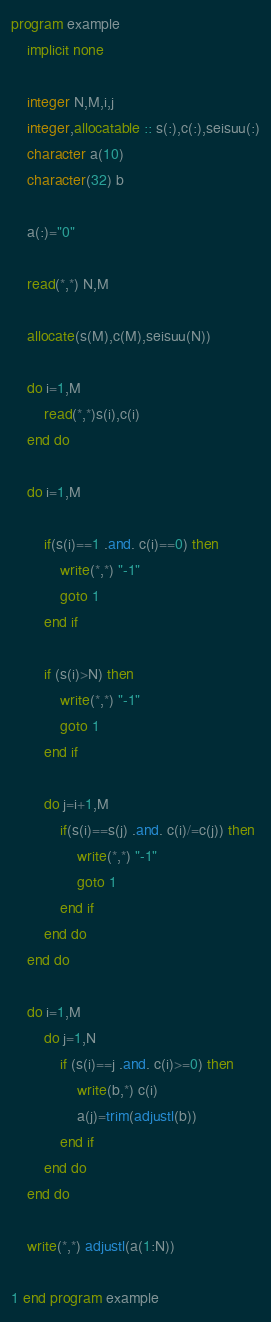Convert code to text. <code><loc_0><loc_0><loc_500><loc_500><_FORTRAN_>program example
	implicit none

	integer N,M,i,j
    integer,allocatable :: s(:),c(:),seisuu(:)
	character a(10)
    character(32) b

	a(:)="0"

    read(*,*) N,M
    
    allocate(s(M),c(M),seisuu(N))
    
    do i=1,M
    	read(*,*)s(i),c(i)
	end do
    
    do i=1,M
    
    	if(s(i)==1 .and. c(i)==0) then
        	write(*,*) "-1"
            goto 1
    	end if
        
        if (s(i)>N) then
        	write(*,*) "-1"
            goto 1	
        end if
    
    	do j=i+1,M
        	if(s(i)==s(j) .and. c(i)/=c(j)) then
            	write(*,*) "-1"
                goto 1
            end if
        end do
    end do
    
    do i=1,M
    	do j=1,N
			if (s(i)==j .and. c(i)>=0) then
            	write(b,*) c(i)
        		a(j)=trim(adjustl(b))
            end if
        end do
    end do
    
    write(*,*) adjustl(a(1:N))
                
1 end program example</code> 